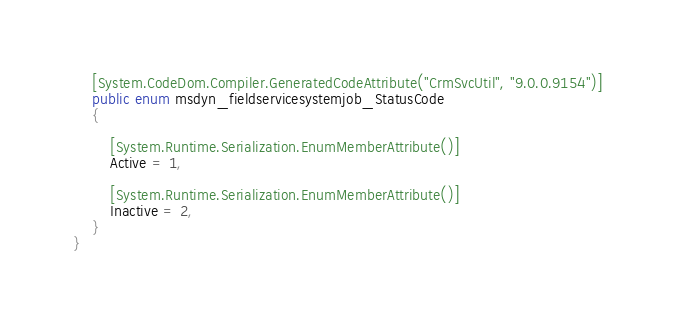<code> <loc_0><loc_0><loc_500><loc_500><_C#_>	[System.CodeDom.Compiler.GeneratedCodeAttribute("CrmSvcUtil", "9.0.0.9154")]
	public enum msdyn_fieldservicesystemjob_StatusCode
	{
		
		[System.Runtime.Serialization.EnumMemberAttribute()]
		Active = 1,
		
		[System.Runtime.Serialization.EnumMemberAttribute()]
		Inactive = 2,
	}
}</code> 